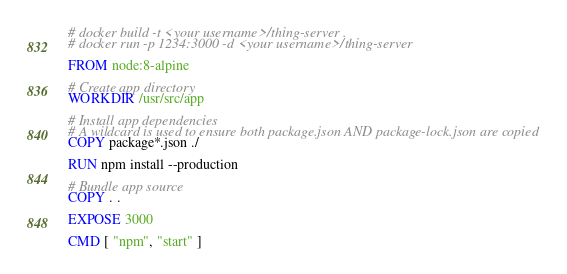Convert code to text. <code><loc_0><loc_0><loc_500><loc_500><_Dockerfile_># docker build -t <your username>/thing-server .
# docker run -p 1234:3000 -d <your username>/thing-server

FROM node:8-alpine

# Create app directory
WORKDIR /usr/src/app

# Install app dependencies
# A wildcard is used to ensure both package.json AND package-lock.json are copied
COPY package*.json ./

RUN npm install --production

# Bundle app source
COPY . .

EXPOSE 3000

CMD [ "npm", "start" ]</code> 